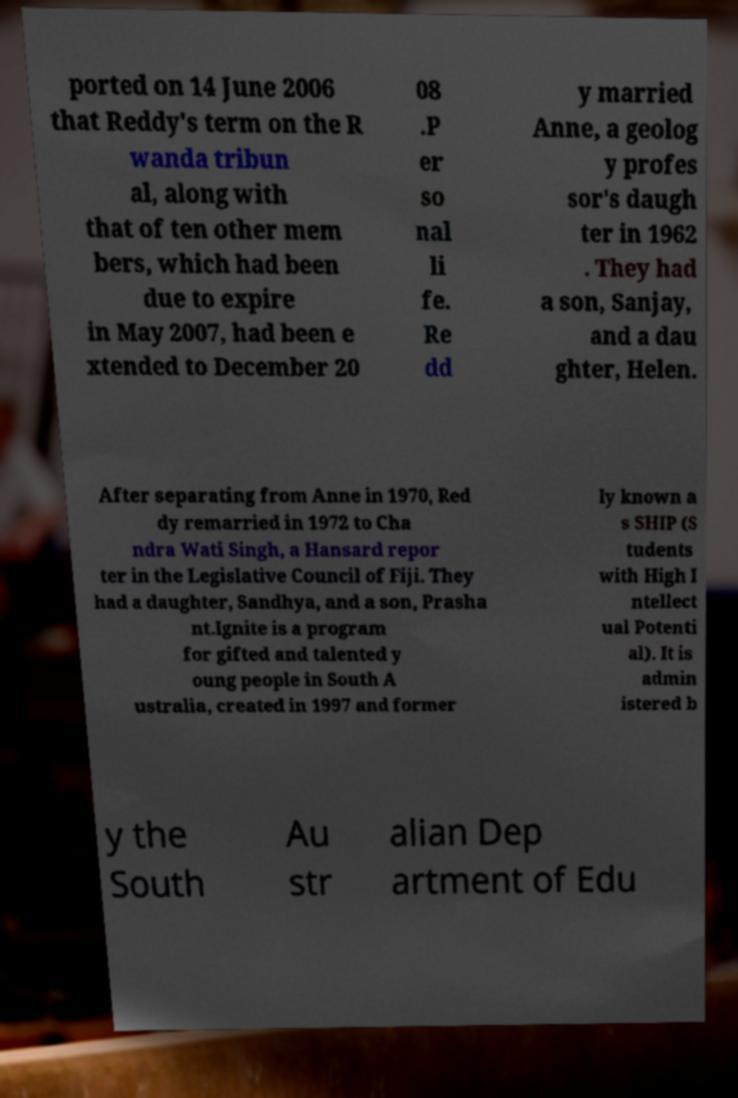What messages or text are displayed in this image? I need them in a readable, typed format. ported on 14 June 2006 that Reddy's term on the R wanda tribun al, along with that of ten other mem bers, which had been due to expire in May 2007, had been e xtended to December 20 08 .P er so nal li fe. Re dd y married Anne, a geolog y profes sor's daugh ter in 1962 . They had a son, Sanjay, and a dau ghter, Helen. After separating from Anne in 1970, Red dy remarried in 1972 to Cha ndra Wati Singh, a Hansard repor ter in the Legislative Council of Fiji. They had a daughter, Sandhya, and a son, Prasha nt.Ignite is a program for gifted and talented y oung people in South A ustralia, created in 1997 and former ly known a s SHIP (S tudents with High I ntellect ual Potenti al). It is admin istered b y the South Au str alian Dep artment of Edu 